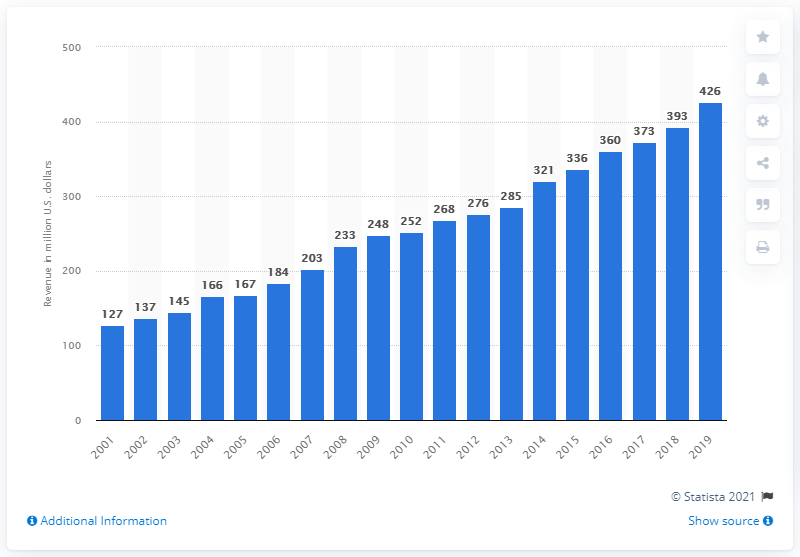Indicate a few pertinent items in this graphic. In 2019, the revenue of the Indianapolis Colts was 426 million dollars. 